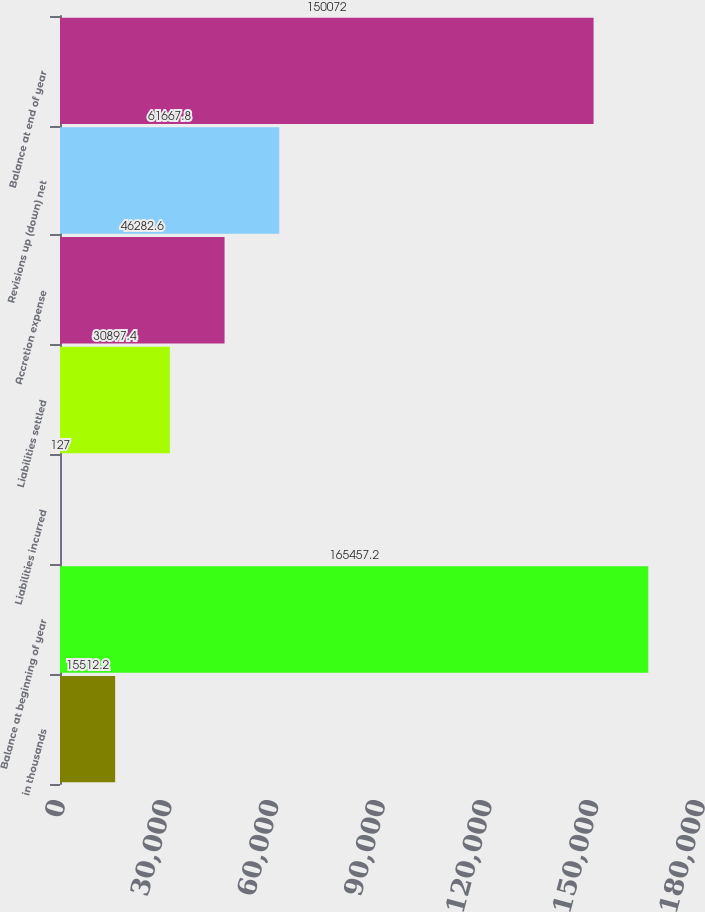Convert chart. <chart><loc_0><loc_0><loc_500><loc_500><bar_chart><fcel>in thousands<fcel>Balance at beginning of year<fcel>Liabilities incurred<fcel>Liabilities settled<fcel>Accretion expense<fcel>Revisions up (down) net<fcel>Balance at end of year<nl><fcel>15512.2<fcel>165457<fcel>127<fcel>30897.4<fcel>46282.6<fcel>61667.8<fcel>150072<nl></chart> 